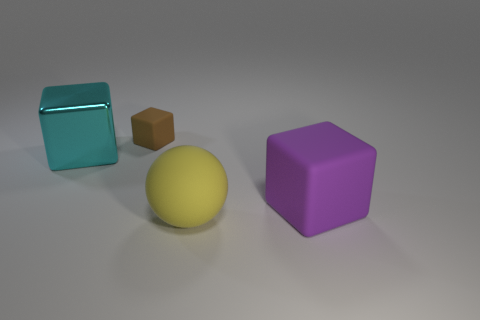Are there any other things that are made of the same material as the cyan thing?
Ensure brevity in your answer.  No. There is a big cube that is behind the large block that is on the right side of the cyan block; what is its material?
Your response must be concise. Metal. What number of big purple rubber objects are the same shape as the tiny brown object?
Your answer should be compact. 1. Is there a big matte sphere that has the same color as the big shiny block?
Your answer should be compact. No. What number of objects are either objects that are right of the small matte object or big things that are to the right of the tiny matte cube?
Give a very brief answer. 2. There is a matte cube that is on the right side of the brown rubber object; is there a small brown cube that is in front of it?
Ensure brevity in your answer.  No. What shape is the purple matte object that is the same size as the cyan thing?
Provide a succinct answer. Cube. What number of objects are small cubes behind the big metal cube or large red cubes?
Your response must be concise. 1. What number of other things are there of the same material as the large cyan block
Your response must be concise. 0. How big is the rubber cube left of the large ball?
Your answer should be very brief. Small. 